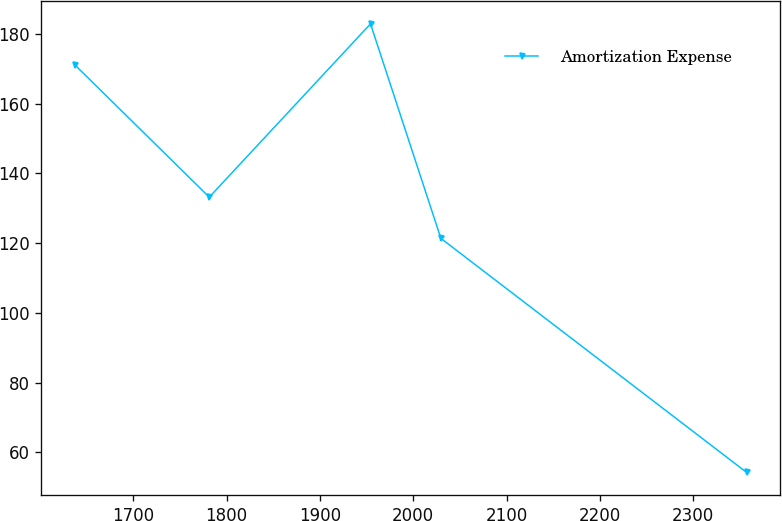Convert chart. <chart><loc_0><loc_0><loc_500><loc_500><line_chart><ecel><fcel>Amortization Expense<nl><fcel>1637.57<fcel>171.1<nl><fcel>1781.43<fcel>133.21<nl><fcel>1954.19<fcel>182.91<nl><fcel>2029.58<fcel>121.4<nl><fcel>2357.21<fcel>54.28<nl></chart> 